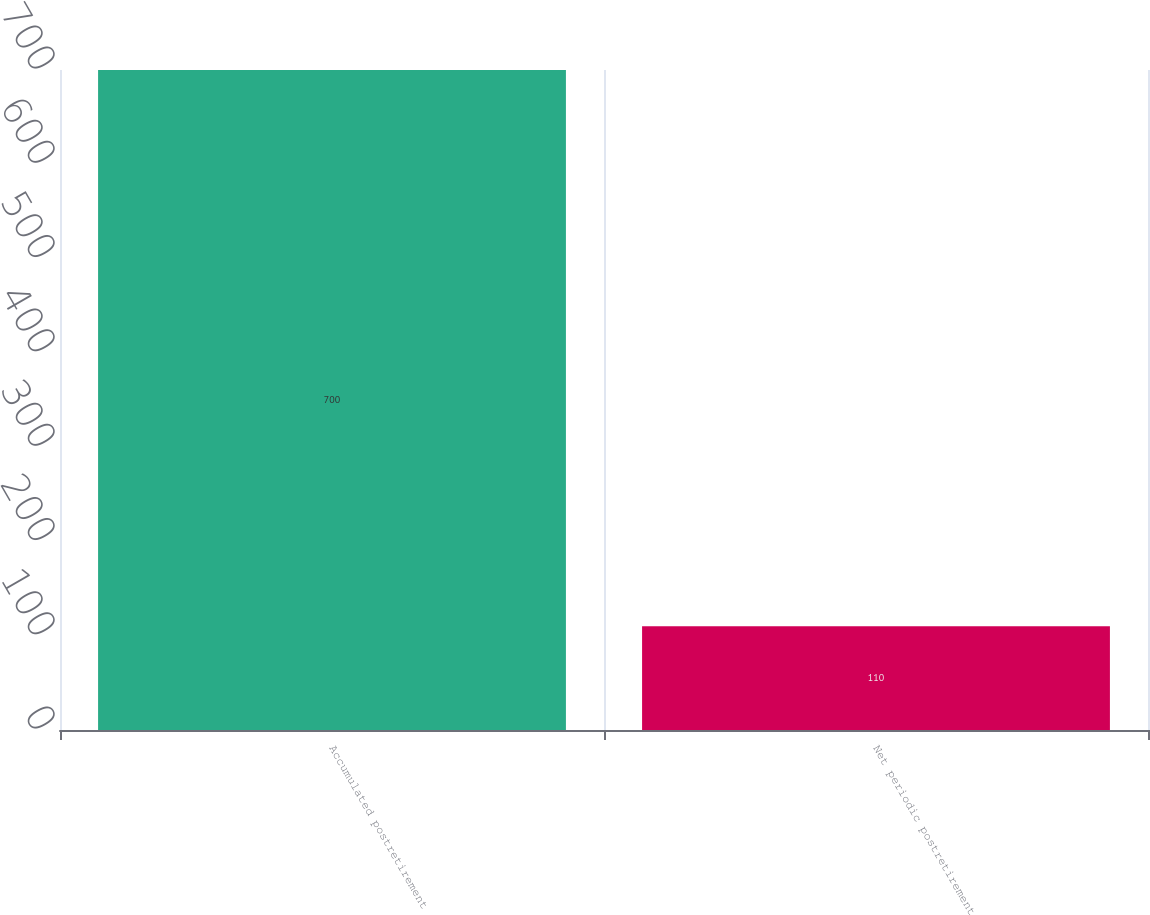<chart> <loc_0><loc_0><loc_500><loc_500><bar_chart><fcel>Accumulated postretirement<fcel>Net periodic postretirement<nl><fcel>700<fcel>110<nl></chart> 